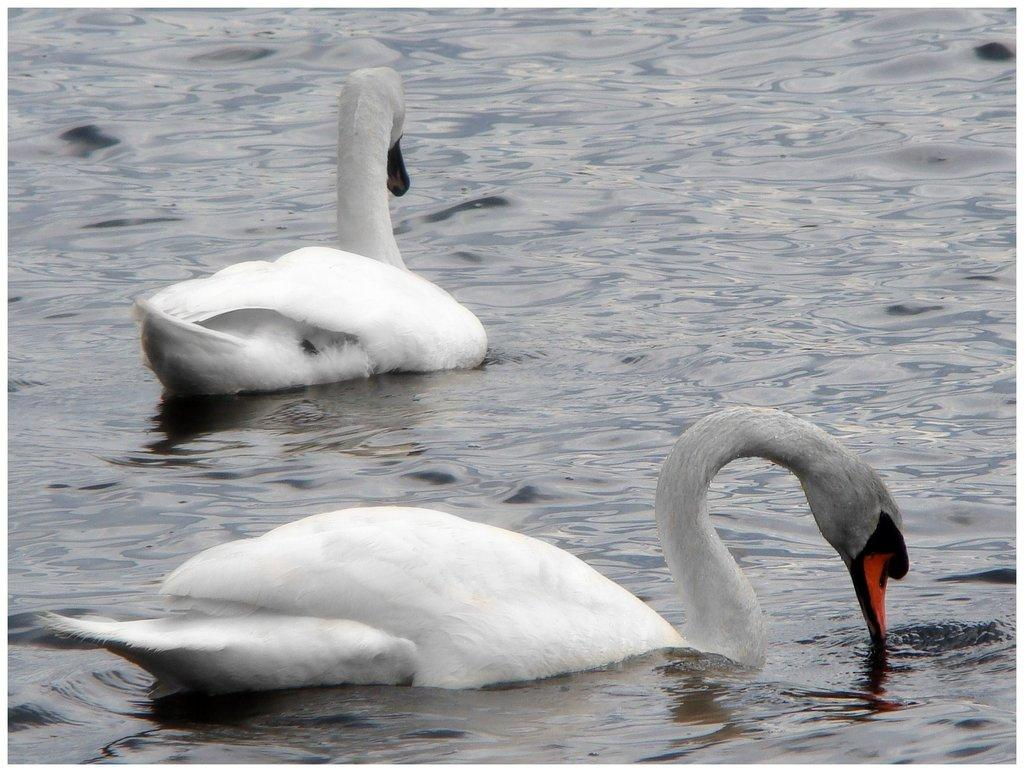What type of animals are in the image? There are white ducks in the image. Where are the ducks located? The ducks are in the water. What type of shade is being provided by the wren in the image? There is no wren present in the image, so no shade is being provided by a wren. How many mittens can be seen in the image? There are no mittens present in the image. 